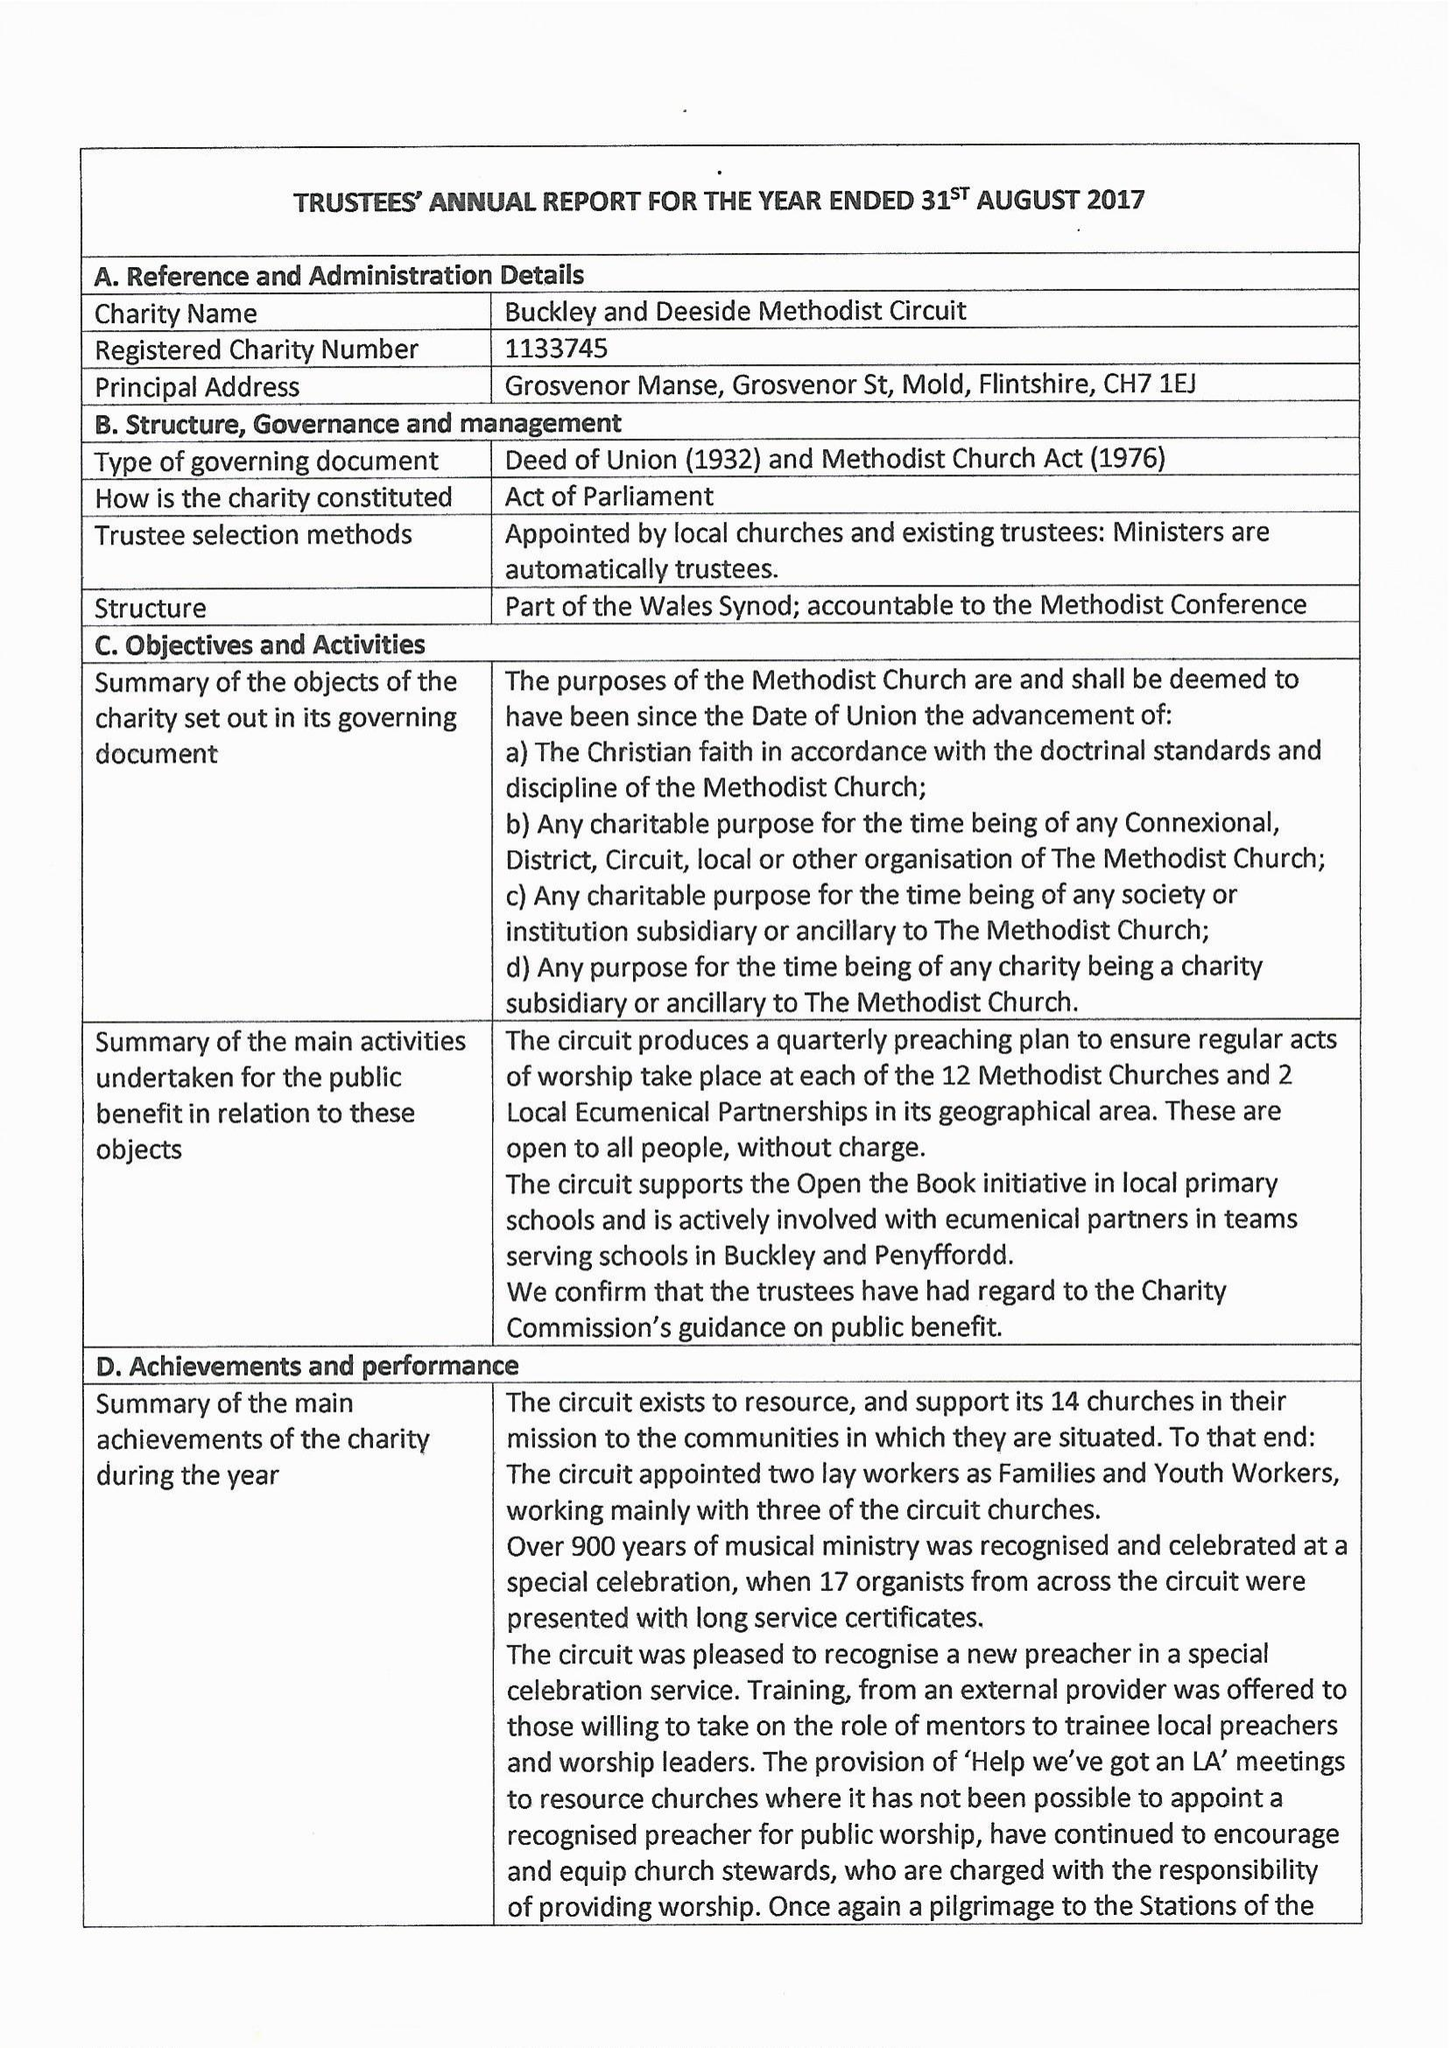What is the value for the charity_name?
Answer the question using a single word or phrase. Buckley and Deeside Methodist Circuit 